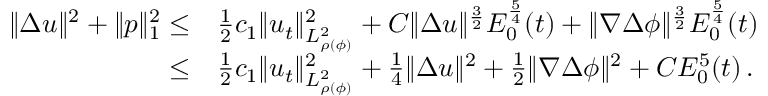<formula> <loc_0><loc_0><loc_500><loc_500>\begin{array} { r l } { \| \Delta u \| ^ { 2 } + \| p \| _ { 1 } ^ { 2 } \leq } & { \frac { 1 } { 2 } c _ { 1 } \| u _ { t } \| _ { L _ { \rho ( \phi ) } ^ { 2 } } ^ { 2 } + C \| \Delta u \| ^ { \frac { 3 } { 2 } } E _ { 0 } ^ { \frac { 5 } { 4 } } ( t ) + \| \nabla \Delta \phi \| ^ { \frac { 3 } { 2 } } E _ { 0 } ^ { \frac { 5 } { 4 } } ( t ) } \\ { \leq } & { \frac { 1 } { 2 } c _ { 1 } \| u _ { t } \| _ { L _ { \rho ( \phi ) } ^ { 2 } } ^ { 2 } + \frac { 1 } { 4 } \| \Delta u \| ^ { 2 } + \frac { 1 } { 2 } \| \nabla \Delta \phi \| ^ { 2 } + C E _ { 0 } ^ { 5 } ( t ) \, . } \end{array}</formula> 